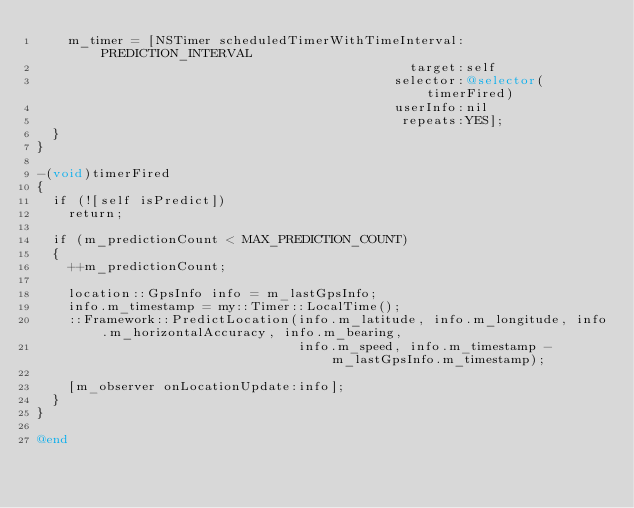<code> <loc_0><loc_0><loc_500><loc_500><_ObjectiveC_>    m_timer = [NSTimer scheduledTimerWithTimeInterval:PREDICTION_INTERVAL
                                               target:self
                                             selector:@selector(timerFired)
                                             userInfo:nil
                                              repeats:YES];
  }
}

-(void)timerFired
{
  if (![self isPredict])
    return;
  
  if (m_predictionCount < MAX_PREDICTION_COUNT)
  {
    ++m_predictionCount;

    location::GpsInfo info = m_lastGpsInfo;
    info.m_timestamp = my::Timer::LocalTime();
    ::Framework::PredictLocation(info.m_latitude, info.m_longitude, info.m_horizontalAccuracy, info.m_bearing,
                                 info.m_speed, info.m_timestamp - m_lastGpsInfo.m_timestamp);
    
    [m_observer onLocationUpdate:info];
  }
}

@end
</code> 